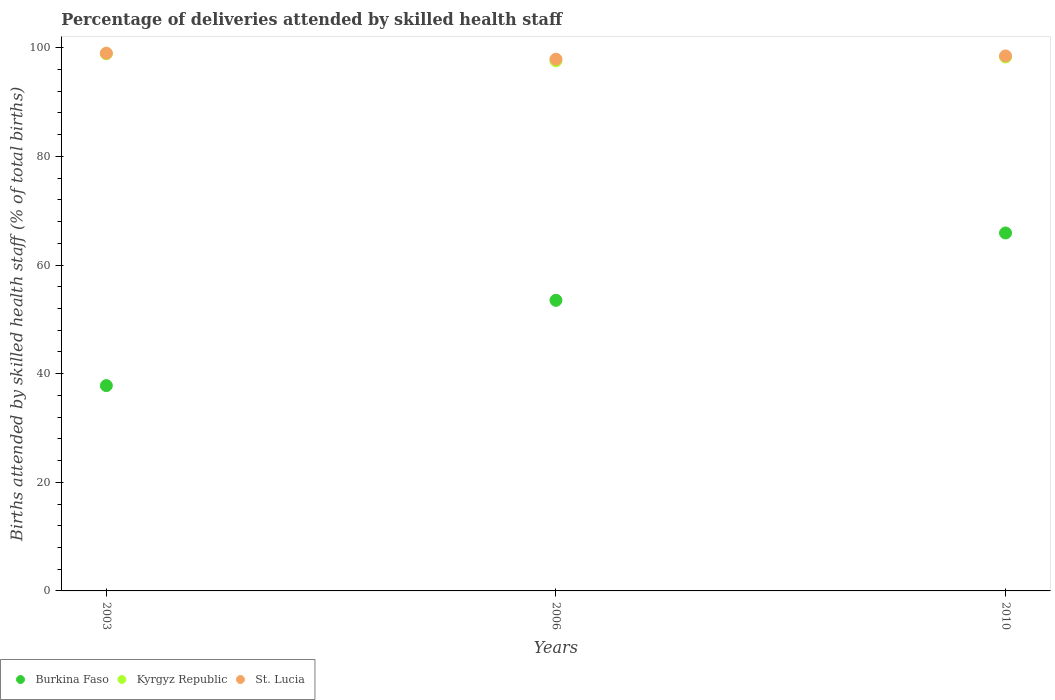How many different coloured dotlines are there?
Keep it short and to the point. 3. What is the percentage of births attended by skilled health staff in St. Lucia in 2010?
Your response must be concise. 98.5. Across all years, what is the maximum percentage of births attended by skilled health staff in Kyrgyz Republic?
Provide a short and direct response. 98.9. Across all years, what is the minimum percentage of births attended by skilled health staff in Burkina Faso?
Ensure brevity in your answer.  37.8. What is the total percentage of births attended by skilled health staff in St. Lucia in the graph?
Make the answer very short. 295.4. What is the difference between the percentage of births attended by skilled health staff in Kyrgyz Republic in 2006 and that in 2010?
Offer a very short reply. -0.7. What is the difference between the percentage of births attended by skilled health staff in Kyrgyz Republic in 2006 and the percentage of births attended by skilled health staff in St. Lucia in 2010?
Offer a very short reply. -0.9. What is the average percentage of births attended by skilled health staff in Burkina Faso per year?
Provide a succinct answer. 52.4. In the year 2003, what is the difference between the percentage of births attended by skilled health staff in St. Lucia and percentage of births attended by skilled health staff in Kyrgyz Republic?
Give a very brief answer. 0.1. In how many years, is the percentage of births attended by skilled health staff in St. Lucia greater than 68 %?
Make the answer very short. 3. What is the ratio of the percentage of births attended by skilled health staff in St. Lucia in 2006 to that in 2010?
Provide a short and direct response. 0.99. Is the percentage of births attended by skilled health staff in Burkina Faso in 2003 less than that in 2010?
Offer a very short reply. Yes. Is the difference between the percentage of births attended by skilled health staff in St. Lucia in 2003 and 2010 greater than the difference between the percentage of births attended by skilled health staff in Kyrgyz Republic in 2003 and 2010?
Give a very brief answer. No. What is the difference between the highest and the second highest percentage of births attended by skilled health staff in Burkina Faso?
Keep it short and to the point. 12.4. What is the difference between the highest and the lowest percentage of births attended by skilled health staff in Burkina Faso?
Provide a succinct answer. 28.1. In how many years, is the percentage of births attended by skilled health staff in St. Lucia greater than the average percentage of births attended by skilled health staff in St. Lucia taken over all years?
Ensure brevity in your answer.  2. Is the sum of the percentage of births attended by skilled health staff in Kyrgyz Republic in 2003 and 2010 greater than the maximum percentage of births attended by skilled health staff in St. Lucia across all years?
Offer a very short reply. Yes. Does the percentage of births attended by skilled health staff in Kyrgyz Republic monotonically increase over the years?
Give a very brief answer. No. Is the percentage of births attended by skilled health staff in Burkina Faso strictly less than the percentage of births attended by skilled health staff in St. Lucia over the years?
Make the answer very short. Yes. How many dotlines are there?
Your answer should be very brief. 3. What is the difference between two consecutive major ticks on the Y-axis?
Offer a very short reply. 20. Does the graph contain any zero values?
Your answer should be compact. No. Does the graph contain grids?
Provide a succinct answer. No. How many legend labels are there?
Make the answer very short. 3. What is the title of the graph?
Make the answer very short. Percentage of deliveries attended by skilled health staff. What is the label or title of the Y-axis?
Offer a very short reply. Births attended by skilled health staff (% of total births). What is the Births attended by skilled health staff (% of total births) of Burkina Faso in 2003?
Keep it short and to the point. 37.8. What is the Births attended by skilled health staff (% of total births) of Kyrgyz Republic in 2003?
Offer a very short reply. 98.9. What is the Births attended by skilled health staff (% of total births) in St. Lucia in 2003?
Offer a terse response. 99. What is the Births attended by skilled health staff (% of total births) in Burkina Faso in 2006?
Ensure brevity in your answer.  53.5. What is the Births attended by skilled health staff (% of total births) of Kyrgyz Republic in 2006?
Ensure brevity in your answer.  97.6. What is the Births attended by skilled health staff (% of total births) of St. Lucia in 2006?
Your answer should be very brief. 97.9. What is the Births attended by skilled health staff (% of total births) of Burkina Faso in 2010?
Provide a short and direct response. 65.9. What is the Births attended by skilled health staff (% of total births) in Kyrgyz Republic in 2010?
Offer a terse response. 98.3. What is the Births attended by skilled health staff (% of total births) of St. Lucia in 2010?
Provide a succinct answer. 98.5. Across all years, what is the maximum Births attended by skilled health staff (% of total births) of Burkina Faso?
Keep it short and to the point. 65.9. Across all years, what is the maximum Births attended by skilled health staff (% of total births) in Kyrgyz Republic?
Offer a terse response. 98.9. Across all years, what is the minimum Births attended by skilled health staff (% of total births) of Burkina Faso?
Your response must be concise. 37.8. Across all years, what is the minimum Births attended by skilled health staff (% of total births) in Kyrgyz Republic?
Make the answer very short. 97.6. Across all years, what is the minimum Births attended by skilled health staff (% of total births) in St. Lucia?
Make the answer very short. 97.9. What is the total Births attended by skilled health staff (% of total births) in Burkina Faso in the graph?
Your answer should be compact. 157.2. What is the total Births attended by skilled health staff (% of total births) of Kyrgyz Republic in the graph?
Make the answer very short. 294.8. What is the total Births attended by skilled health staff (% of total births) in St. Lucia in the graph?
Make the answer very short. 295.4. What is the difference between the Births attended by skilled health staff (% of total births) in Burkina Faso in 2003 and that in 2006?
Make the answer very short. -15.7. What is the difference between the Births attended by skilled health staff (% of total births) in Burkina Faso in 2003 and that in 2010?
Your response must be concise. -28.1. What is the difference between the Births attended by skilled health staff (% of total births) in Kyrgyz Republic in 2003 and that in 2010?
Give a very brief answer. 0.6. What is the difference between the Births attended by skilled health staff (% of total births) of St. Lucia in 2003 and that in 2010?
Provide a succinct answer. 0.5. What is the difference between the Births attended by skilled health staff (% of total births) in Burkina Faso in 2006 and that in 2010?
Make the answer very short. -12.4. What is the difference between the Births attended by skilled health staff (% of total births) in Kyrgyz Republic in 2006 and that in 2010?
Your response must be concise. -0.7. What is the difference between the Births attended by skilled health staff (% of total births) in Burkina Faso in 2003 and the Births attended by skilled health staff (% of total births) in Kyrgyz Republic in 2006?
Make the answer very short. -59.8. What is the difference between the Births attended by skilled health staff (% of total births) in Burkina Faso in 2003 and the Births attended by skilled health staff (% of total births) in St. Lucia in 2006?
Your answer should be very brief. -60.1. What is the difference between the Births attended by skilled health staff (% of total births) in Kyrgyz Republic in 2003 and the Births attended by skilled health staff (% of total births) in St. Lucia in 2006?
Ensure brevity in your answer.  1. What is the difference between the Births attended by skilled health staff (% of total births) of Burkina Faso in 2003 and the Births attended by skilled health staff (% of total births) of Kyrgyz Republic in 2010?
Give a very brief answer. -60.5. What is the difference between the Births attended by skilled health staff (% of total births) in Burkina Faso in 2003 and the Births attended by skilled health staff (% of total births) in St. Lucia in 2010?
Provide a short and direct response. -60.7. What is the difference between the Births attended by skilled health staff (% of total births) in Burkina Faso in 2006 and the Births attended by skilled health staff (% of total births) in Kyrgyz Republic in 2010?
Offer a very short reply. -44.8. What is the difference between the Births attended by skilled health staff (% of total births) in Burkina Faso in 2006 and the Births attended by skilled health staff (% of total births) in St. Lucia in 2010?
Your answer should be compact. -45. What is the average Births attended by skilled health staff (% of total births) of Burkina Faso per year?
Keep it short and to the point. 52.4. What is the average Births attended by skilled health staff (% of total births) of Kyrgyz Republic per year?
Offer a very short reply. 98.27. What is the average Births attended by skilled health staff (% of total births) of St. Lucia per year?
Give a very brief answer. 98.47. In the year 2003, what is the difference between the Births attended by skilled health staff (% of total births) in Burkina Faso and Births attended by skilled health staff (% of total births) in Kyrgyz Republic?
Provide a succinct answer. -61.1. In the year 2003, what is the difference between the Births attended by skilled health staff (% of total births) of Burkina Faso and Births attended by skilled health staff (% of total births) of St. Lucia?
Offer a terse response. -61.2. In the year 2006, what is the difference between the Births attended by skilled health staff (% of total births) in Burkina Faso and Births attended by skilled health staff (% of total births) in Kyrgyz Republic?
Offer a terse response. -44.1. In the year 2006, what is the difference between the Births attended by skilled health staff (% of total births) of Burkina Faso and Births attended by skilled health staff (% of total births) of St. Lucia?
Give a very brief answer. -44.4. In the year 2006, what is the difference between the Births attended by skilled health staff (% of total births) of Kyrgyz Republic and Births attended by skilled health staff (% of total births) of St. Lucia?
Your response must be concise. -0.3. In the year 2010, what is the difference between the Births attended by skilled health staff (% of total births) of Burkina Faso and Births attended by skilled health staff (% of total births) of Kyrgyz Republic?
Offer a very short reply. -32.4. In the year 2010, what is the difference between the Births attended by skilled health staff (% of total births) in Burkina Faso and Births attended by skilled health staff (% of total births) in St. Lucia?
Your answer should be very brief. -32.6. In the year 2010, what is the difference between the Births attended by skilled health staff (% of total births) in Kyrgyz Republic and Births attended by skilled health staff (% of total births) in St. Lucia?
Your response must be concise. -0.2. What is the ratio of the Births attended by skilled health staff (% of total births) in Burkina Faso in 2003 to that in 2006?
Offer a very short reply. 0.71. What is the ratio of the Births attended by skilled health staff (% of total births) of Kyrgyz Republic in 2003 to that in 2006?
Give a very brief answer. 1.01. What is the ratio of the Births attended by skilled health staff (% of total births) of St. Lucia in 2003 to that in 2006?
Offer a terse response. 1.01. What is the ratio of the Births attended by skilled health staff (% of total births) of Burkina Faso in 2003 to that in 2010?
Your answer should be very brief. 0.57. What is the ratio of the Births attended by skilled health staff (% of total births) of Kyrgyz Republic in 2003 to that in 2010?
Your answer should be very brief. 1.01. What is the ratio of the Births attended by skilled health staff (% of total births) of St. Lucia in 2003 to that in 2010?
Provide a short and direct response. 1.01. What is the ratio of the Births attended by skilled health staff (% of total births) of Burkina Faso in 2006 to that in 2010?
Your answer should be very brief. 0.81. What is the ratio of the Births attended by skilled health staff (% of total births) in Kyrgyz Republic in 2006 to that in 2010?
Give a very brief answer. 0.99. What is the ratio of the Births attended by skilled health staff (% of total births) in St. Lucia in 2006 to that in 2010?
Ensure brevity in your answer.  0.99. What is the difference between the highest and the second highest Births attended by skilled health staff (% of total births) of Kyrgyz Republic?
Offer a very short reply. 0.6. What is the difference between the highest and the second highest Births attended by skilled health staff (% of total births) of St. Lucia?
Make the answer very short. 0.5. What is the difference between the highest and the lowest Births attended by skilled health staff (% of total births) in Burkina Faso?
Give a very brief answer. 28.1. What is the difference between the highest and the lowest Births attended by skilled health staff (% of total births) of Kyrgyz Republic?
Your response must be concise. 1.3. 